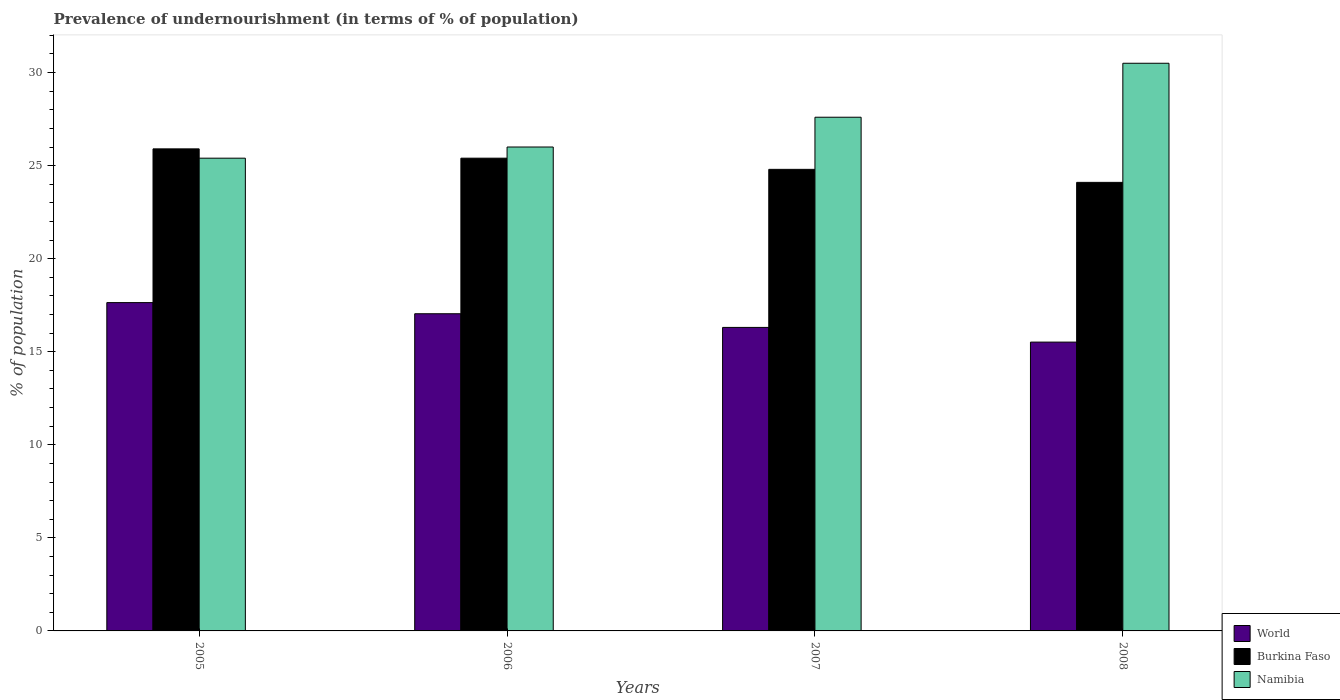Are the number of bars per tick equal to the number of legend labels?
Ensure brevity in your answer.  Yes. In how many cases, is the number of bars for a given year not equal to the number of legend labels?
Your response must be concise. 0. What is the percentage of undernourished population in Burkina Faso in 2008?
Give a very brief answer. 24.1. Across all years, what is the maximum percentage of undernourished population in World?
Your response must be concise. 17.64. Across all years, what is the minimum percentage of undernourished population in Burkina Faso?
Ensure brevity in your answer.  24.1. What is the total percentage of undernourished population in World in the graph?
Provide a short and direct response. 66.51. What is the difference between the percentage of undernourished population in Namibia in 2008 and the percentage of undernourished population in Burkina Faso in 2006?
Ensure brevity in your answer.  5.1. What is the average percentage of undernourished population in Burkina Faso per year?
Make the answer very short. 25.05. In the year 2006, what is the difference between the percentage of undernourished population in Namibia and percentage of undernourished population in World?
Keep it short and to the point. 8.96. In how many years, is the percentage of undernourished population in World greater than 16 %?
Your answer should be very brief. 3. What is the ratio of the percentage of undernourished population in Namibia in 2006 to that in 2008?
Provide a short and direct response. 0.85. Is the percentage of undernourished population in Burkina Faso in 2005 less than that in 2008?
Your response must be concise. No. What is the difference between the highest and the second highest percentage of undernourished population in Namibia?
Your answer should be very brief. 2.9. What is the difference between the highest and the lowest percentage of undernourished population in Namibia?
Your response must be concise. 5.1. In how many years, is the percentage of undernourished population in World greater than the average percentage of undernourished population in World taken over all years?
Your response must be concise. 2. What does the 1st bar from the left in 2006 represents?
Keep it short and to the point. World. Is it the case that in every year, the sum of the percentage of undernourished population in Namibia and percentage of undernourished population in Burkina Faso is greater than the percentage of undernourished population in World?
Offer a terse response. Yes. Are the values on the major ticks of Y-axis written in scientific E-notation?
Offer a terse response. No. Does the graph contain any zero values?
Keep it short and to the point. No. Does the graph contain grids?
Provide a short and direct response. No. What is the title of the graph?
Give a very brief answer. Prevalence of undernourishment (in terms of % of population). What is the label or title of the X-axis?
Your answer should be very brief. Years. What is the label or title of the Y-axis?
Provide a succinct answer. % of population. What is the % of population of World in 2005?
Provide a succinct answer. 17.64. What is the % of population of Burkina Faso in 2005?
Provide a succinct answer. 25.9. What is the % of population in Namibia in 2005?
Provide a succinct answer. 25.4. What is the % of population of World in 2006?
Your answer should be compact. 17.04. What is the % of population of Burkina Faso in 2006?
Ensure brevity in your answer.  25.4. What is the % of population in Namibia in 2006?
Keep it short and to the point. 26. What is the % of population in World in 2007?
Offer a terse response. 16.31. What is the % of population of Burkina Faso in 2007?
Give a very brief answer. 24.8. What is the % of population of Namibia in 2007?
Make the answer very short. 27.6. What is the % of population of World in 2008?
Your answer should be compact. 15.52. What is the % of population in Burkina Faso in 2008?
Give a very brief answer. 24.1. What is the % of population in Namibia in 2008?
Your answer should be very brief. 30.5. Across all years, what is the maximum % of population of World?
Ensure brevity in your answer.  17.64. Across all years, what is the maximum % of population of Burkina Faso?
Your answer should be very brief. 25.9. Across all years, what is the maximum % of population of Namibia?
Ensure brevity in your answer.  30.5. Across all years, what is the minimum % of population in World?
Keep it short and to the point. 15.52. Across all years, what is the minimum % of population of Burkina Faso?
Ensure brevity in your answer.  24.1. Across all years, what is the minimum % of population of Namibia?
Make the answer very short. 25.4. What is the total % of population of World in the graph?
Offer a terse response. 66.51. What is the total % of population in Burkina Faso in the graph?
Offer a terse response. 100.2. What is the total % of population of Namibia in the graph?
Give a very brief answer. 109.5. What is the difference between the % of population in World in 2005 and that in 2006?
Offer a very short reply. 0.6. What is the difference between the % of population of World in 2005 and that in 2007?
Provide a succinct answer. 1.33. What is the difference between the % of population of World in 2005 and that in 2008?
Your answer should be compact. 2.12. What is the difference between the % of population in Namibia in 2005 and that in 2008?
Offer a very short reply. -5.1. What is the difference between the % of population in World in 2006 and that in 2007?
Offer a terse response. 0.73. What is the difference between the % of population in Namibia in 2006 and that in 2007?
Make the answer very short. -1.6. What is the difference between the % of population in World in 2006 and that in 2008?
Your response must be concise. 1.52. What is the difference between the % of population in World in 2007 and that in 2008?
Your answer should be compact. 0.79. What is the difference between the % of population of Burkina Faso in 2007 and that in 2008?
Your response must be concise. 0.7. What is the difference between the % of population in World in 2005 and the % of population in Burkina Faso in 2006?
Make the answer very short. -7.76. What is the difference between the % of population in World in 2005 and the % of population in Namibia in 2006?
Provide a succinct answer. -8.36. What is the difference between the % of population of Burkina Faso in 2005 and the % of population of Namibia in 2006?
Your answer should be very brief. -0.1. What is the difference between the % of population in World in 2005 and the % of population in Burkina Faso in 2007?
Offer a terse response. -7.16. What is the difference between the % of population of World in 2005 and the % of population of Namibia in 2007?
Your response must be concise. -9.96. What is the difference between the % of population of World in 2005 and the % of population of Burkina Faso in 2008?
Make the answer very short. -6.46. What is the difference between the % of population in World in 2005 and the % of population in Namibia in 2008?
Your response must be concise. -12.86. What is the difference between the % of population in Burkina Faso in 2005 and the % of population in Namibia in 2008?
Provide a succinct answer. -4.6. What is the difference between the % of population in World in 2006 and the % of population in Burkina Faso in 2007?
Make the answer very short. -7.76. What is the difference between the % of population in World in 2006 and the % of population in Namibia in 2007?
Ensure brevity in your answer.  -10.56. What is the difference between the % of population of World in 2006 and the % of population of Burkina Faso in 2008?
Your response must be concise. -7.06. What is the difference between the % of population of World in 2006 and the % of population of Namibia in 2008?
Offer a terse response. -13.46. What is the difference between the % of population of Burkina Faso in 2006 and the % of population of Namibia in 2008?
Give a very brief answer. -5.1. What is the difference between the % of population in World in 2007 and the % of population in Burkina Faso in 2008?
Offer a very short reply. -7.79. What is the difference between the % of population in World in 2007 and the % of population in Namibia in 2008?
Ensure brevity in your answer.  -14.19. What is the average % of population of World per year?
Your answer should be very brief. 16.63. What is the average % of population in Burkina Faso per year?
Provide a succinct answer. 25.05. What is the average % of population of Namibia per year?
Offer a terse response. 27.38. In the year 2005, what is the difference between the % of population of World and % of population of Burkina Faso?
Ensure brevity in your answer.  -8.26. In the year 2005, what is the difference between the % of population in World and % of population in Namibia?
Provide a short and direct response. -7.76. In the year 2006, what is the difference between the % of population in World and % of population in Burkina Faso?
Your answer should be compact. -8.36. In the year 2006, what is the difference between the % of population in World and % of population in Namibia?
Make the answer very short. -8.96. In the year 2007, what is the difference between the % of population of World and % of population of Burkina Faso?
Ensure brevity in your answer.  -8.49. In the year 2007, what is the difference between the % of population in World and % of population in Namibia?
Ensure brevity in your answer.  -11.29. In the year 2007, what is the difference between the % of population of Burkina Faso and % of population of Namibia?
Your answer should be compact. -2.8. In the year 2008, what is the difference between the % of population of World and % of population of Burkina Faso?
Your response must be concise. -8.58. In the year 2008, what is the difference between the % of population in World and % of population in Namibia?
Provide a short and direct response. -14.98. What is the ratio of the % of population of World in 2005 to that in 2006?
Ensure brevity in your answer.  1.04. What is the ratio of the % of population in Burkina Faso in 2005 to that in 2006?
Your answer should be compact. 1.02. What is the ratio of the % of population in Namibia in 2005 to that in 2006?
Your answer should be very brief. 0.98. What is the ratio of the % of population of World in 2005 to that in 2007?
Your answer should be very brief. 1.08. What is the ratio of the % of population in Burkina Faso in 2005 to that in 2007?
Give a very brief answer. 1.04. What is the ratio of the % of population of Namibia in 2005 to that in 2007?
Keep it short and to the point. 0.92. What is the ratio of the % of population of World in 2005 to that in 2008?
Offer a terse response. 1.14. What is the ratio of the % of population in Burkina Faso in 2005 to that in 2008?
Provide a succinct answer. 1.07. What is the ratio of the % of population of Namibia in 2005 to that in 2008?
Your answer should be very brief. 0.83. What is the ratio of the % of population in World in 2006 to that in 2007?
Make the answer very short. 1.05. What is the ratio of the % of population in Burkina Faso in 2006 to that in 2007?
Keep it short and to the point. 1.02. What is the ratio of the % of population of Namibia in 2006 to that in 2007?
Give a very brief answer. 0.94. What is the ratio of the % of population in World in 2006 to that in 2008?
Provide a succinct answer. 1.1. What is the ratio of the % of population in Burkina Faso in 2006 to that in 2008?
Your response must be concise. 1.05. What is the ratio of the % of population of Namibia in 2006 to that in 2008?
Offer a very short reply. 0.85. What is the ratio of the % of population of World in 2007 to that in 2008?
Your answer should be compact. 1.05. What is the ratio of the % of population of Namibia in 2007 to that in 2008?
Provide a short and direct response. 0.9. What is the difference between the highest and the second highest % of population of World?
Give a very brief answer. 0.6. What is the difference between the highest and the second highest % of population in Burkina Faso?
Make the answer very short. 0.5. What is the difference between the highest and the lowest % of population in World?
Offer a terse response. 2.12. What is the difference between the highest and the lowest % of population of Burkina Faso?
Ensure brevity in your answer.  1.8. 